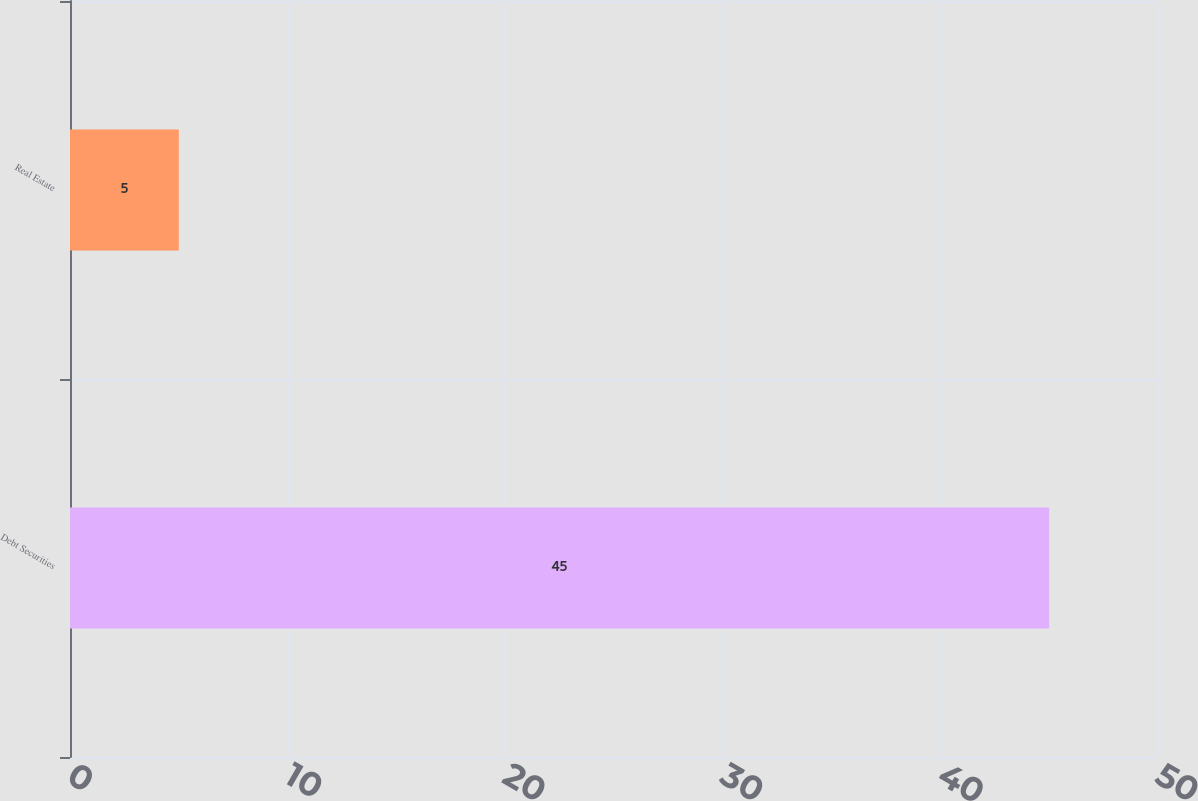Convert chart. <chart><loc_0><loc_0><loc_500><loc_500><bar_chart><fcel>Debt Securities<fcel>Real Estate<nl><fcel>45<fcel>5<nl></chart> 